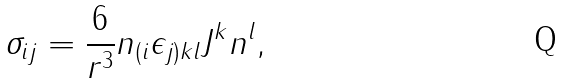Convert formula to latex. <formula><loc_0><loc_0><loc_500><loc_500>\sigma _ { i j } = \frac { 6 } { r ^ { 3 } } n _ { ( i } \epsilon _ { j ) k l } J ^ { k } n ^ { l } ,</formula> 